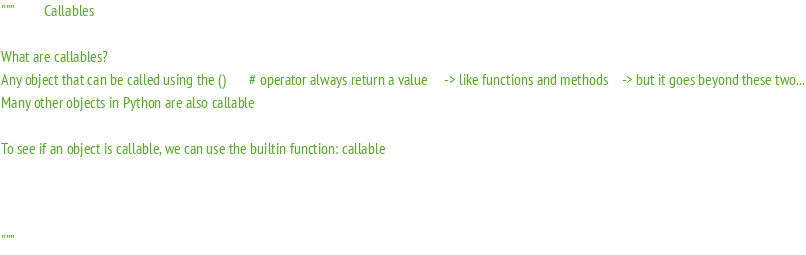Convert code to text. <code><loc_0><loc_0><loc_500><loc_500><_Python_>"""         Callables

What are callables?
Any object that can be called using the ()       # operator always return a value     -> like functions and methods    -> but it goes beyond these two...
Many other objects in Python are also callable

To see if an object is callable, we can use the builtin function: callable



"""</code> 